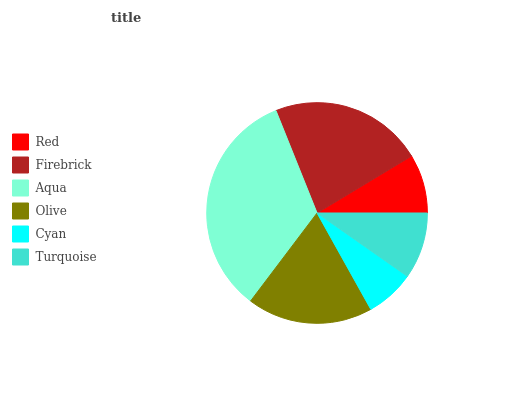Is Cyan the minimum?
Answer yes or no. Yes. Is Aqua the maximum?
Answer yes or no. Yes. Is Firebrick the minimum?
Answer yes or no. No. Is Firebrick the maximum?
Answer yes or no. No. Is Firebrick greater than Red?
Answer yes or no. Yes. Is Red less than Firebrick?
Answer yes or no. Yes. Is Red greater than Firebrick?
Answer yes or no. No. Is Firebrick less than Red?
Answer yes or no. No. Is Olive the high median?
Answer yes or no. Yes. Is Turquoise the low median?
Answer yes or no. Yes. Is Firebrick the high median?
Answer yes or no. No. Is Firebrick the low median?
Answer yes or no. No. 